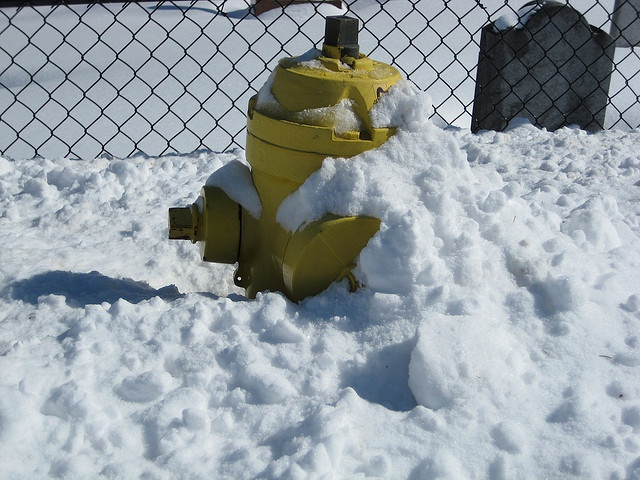Describe the objects in this image and their specific colors. I can see a fire hydrant in black, darkgreen, and gray tones in this image. 